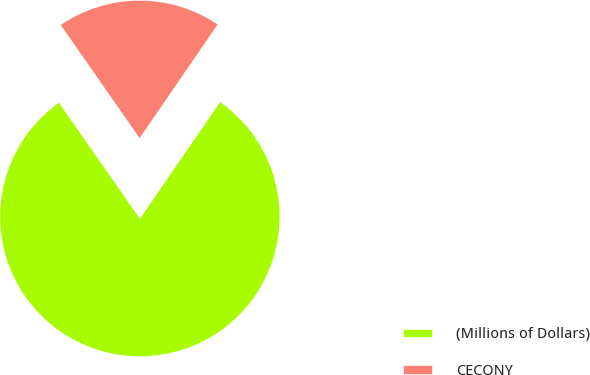Convert chart to OTSL. <chart><loc_0><loc_0><loc_500><loc_500><pie_chart><fcel>(Millions of Dollars)<fcel>CECONY<nl><fcel>80.73%<fcel>19.27%<nl></chart> 